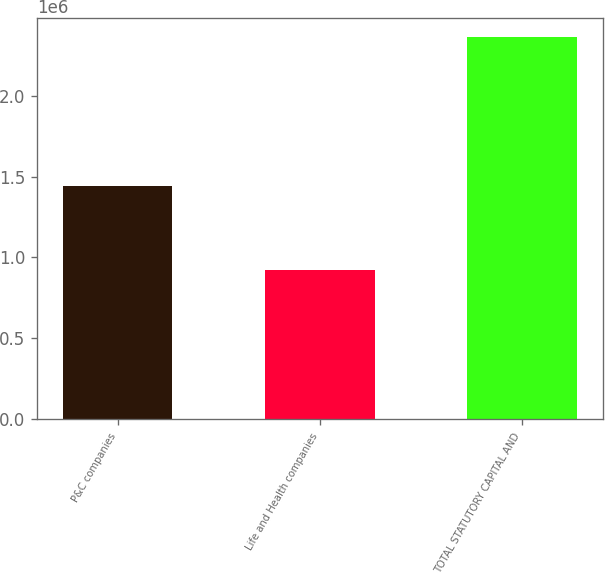<chart> <loc_0><loc_0><loc_500><loc_500><bar_chart><fcel>P&C companies<fcel>Life and Health companies<fcel>TOTAL STATUTORY CAPITAL AND<nl><fcel>1.44039e+06<fcel>923660<fcel>2.36405e+06<nl></chart> 